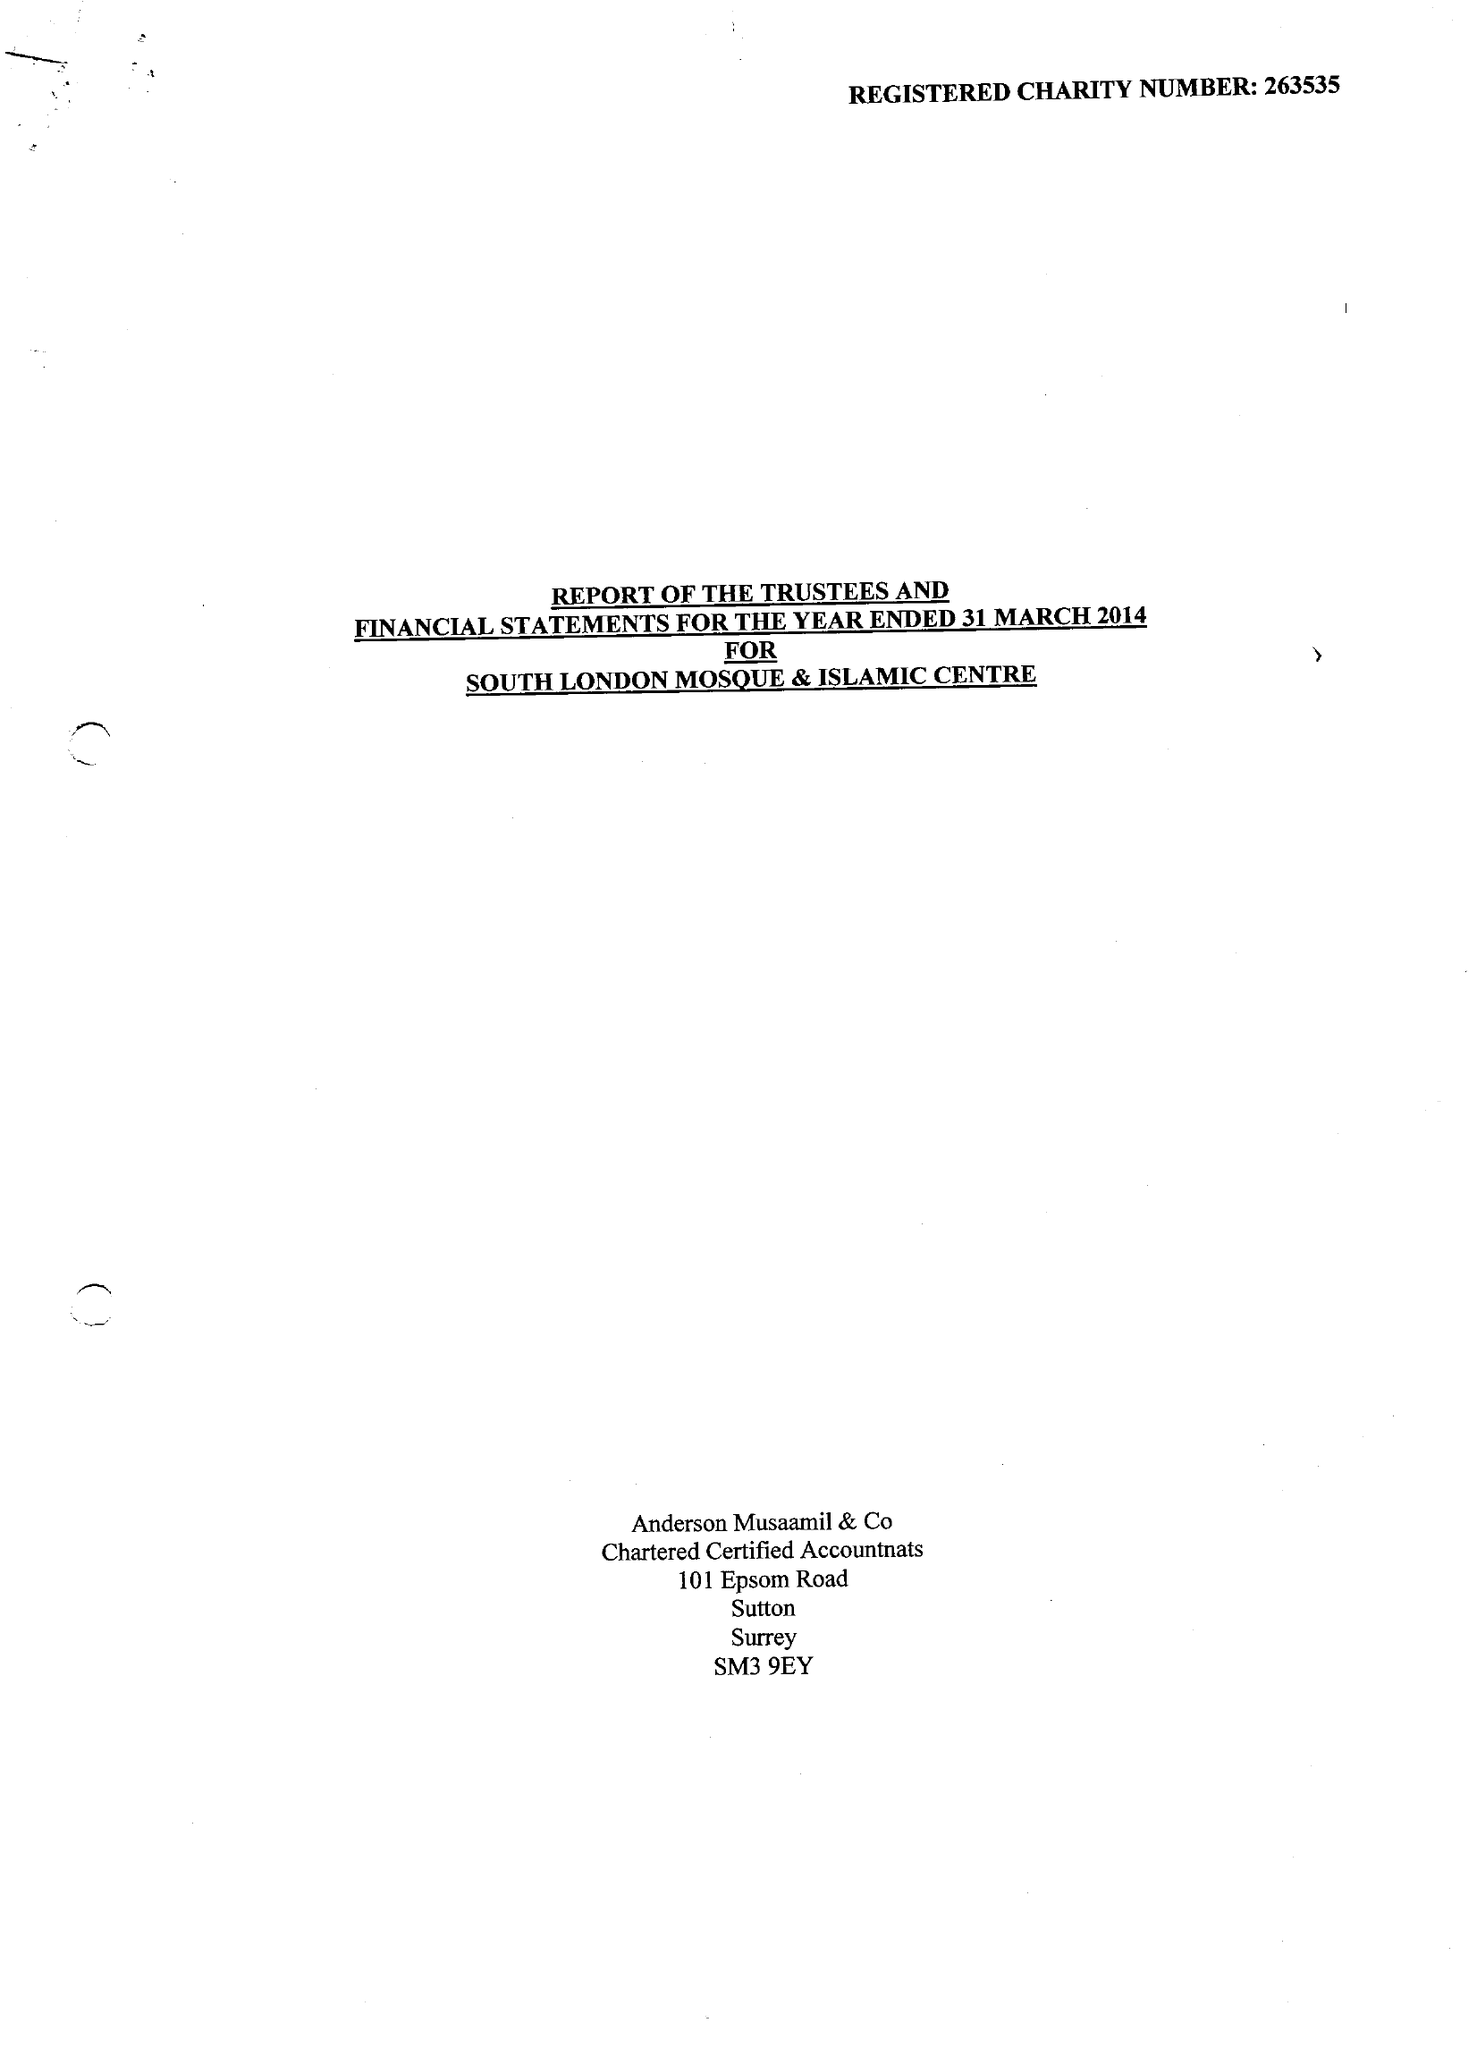What is the value for the spending_annually_in_british_pounds?
Answer the question using a single word or phrase. 213583.00 